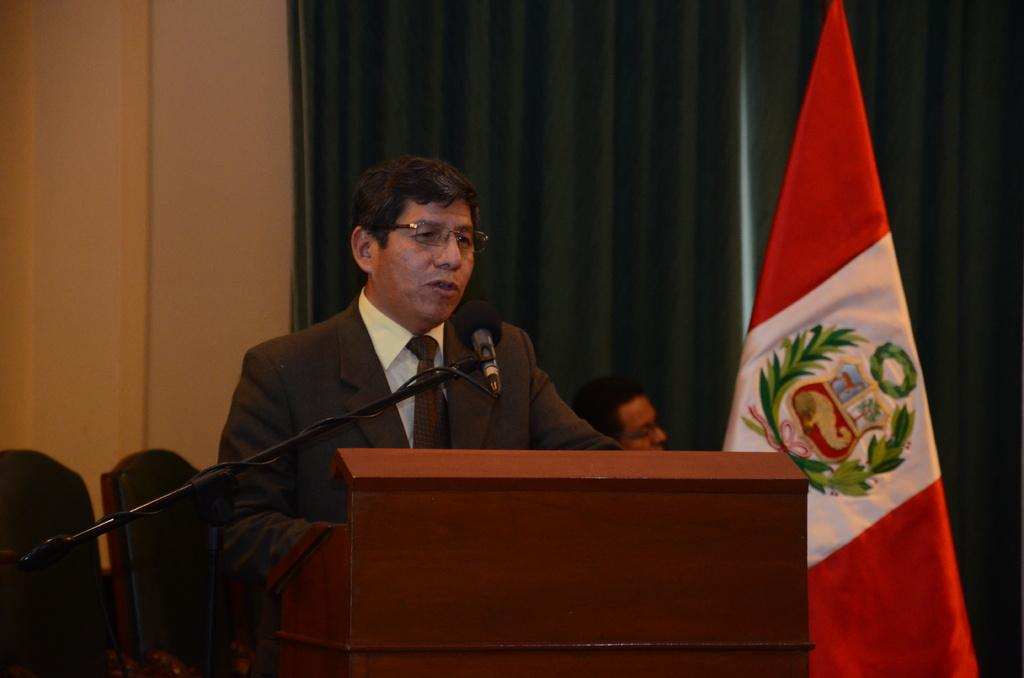What is the main object in the image? There is a podium in the image. What is attached to the podium? There is a microphone in the image. What can be seen near the podium? There is a flag in the image. Who is present in the image? There is a person standing in front of the podium. What can be seen behind the person? There is a wall behind the person, and a curtain is associated with the wall. What else is visible in the image? Person chairs are visible in the image. What type of map is the person holding in the image? There is no map present in the image; the person's backside is visible, and they are not holding anything. 